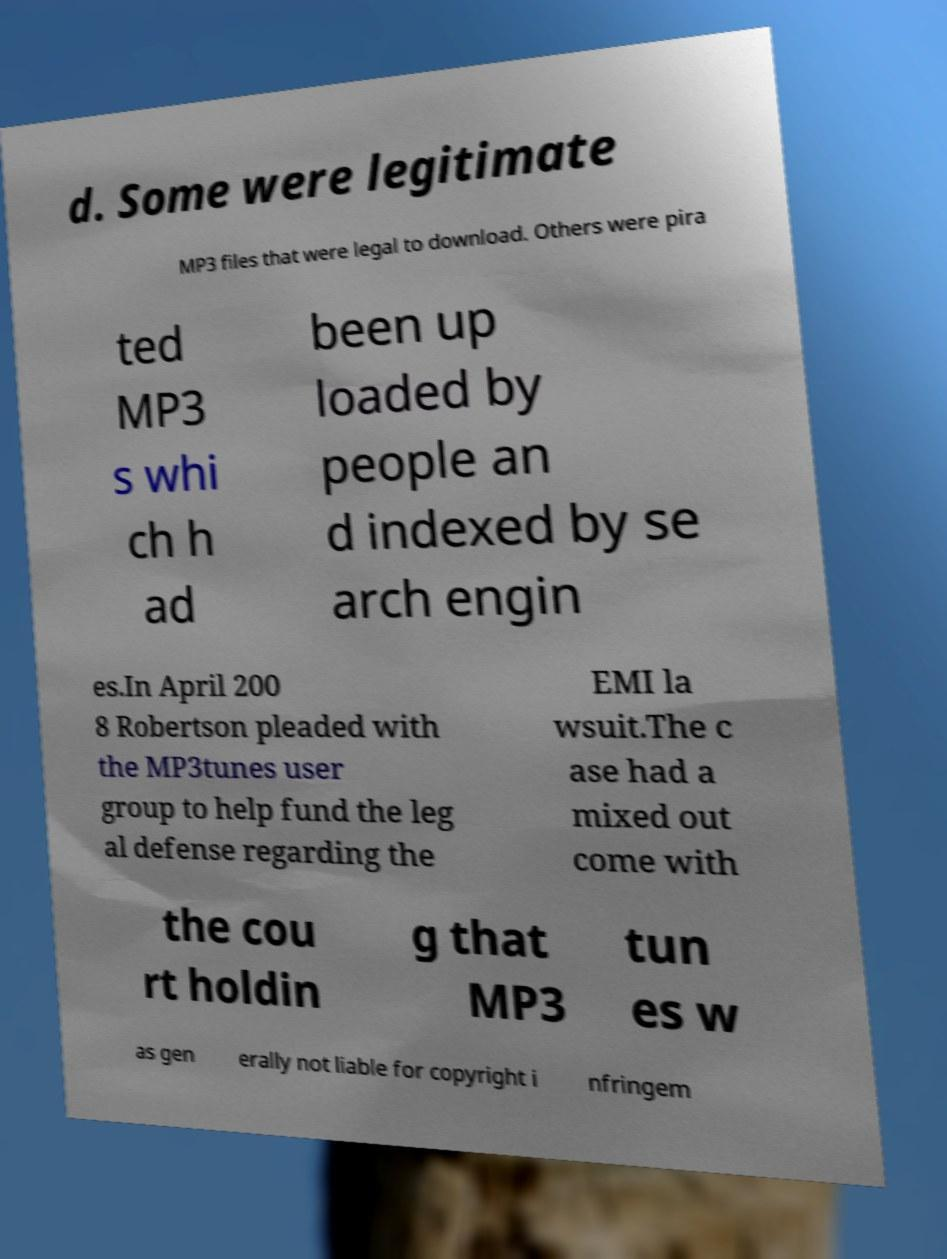There's text embedded in this image that I need extracted. Can you transcribe it verbatim? d. Some were legitimate MP3 files that were legal to download. Others were pira ted MP3 s whi ch h ad been up loaded by people an d indexed by se arch engin es.In April 200 8 Robertson pleaded with the MP3tunes user group to help fund the leg al defense regarding the EMI la wsuit.The c ase had a mixed out come with the cou rt holdin g that MP3 tun es w as gen erally not liable for copyright i nfringem 